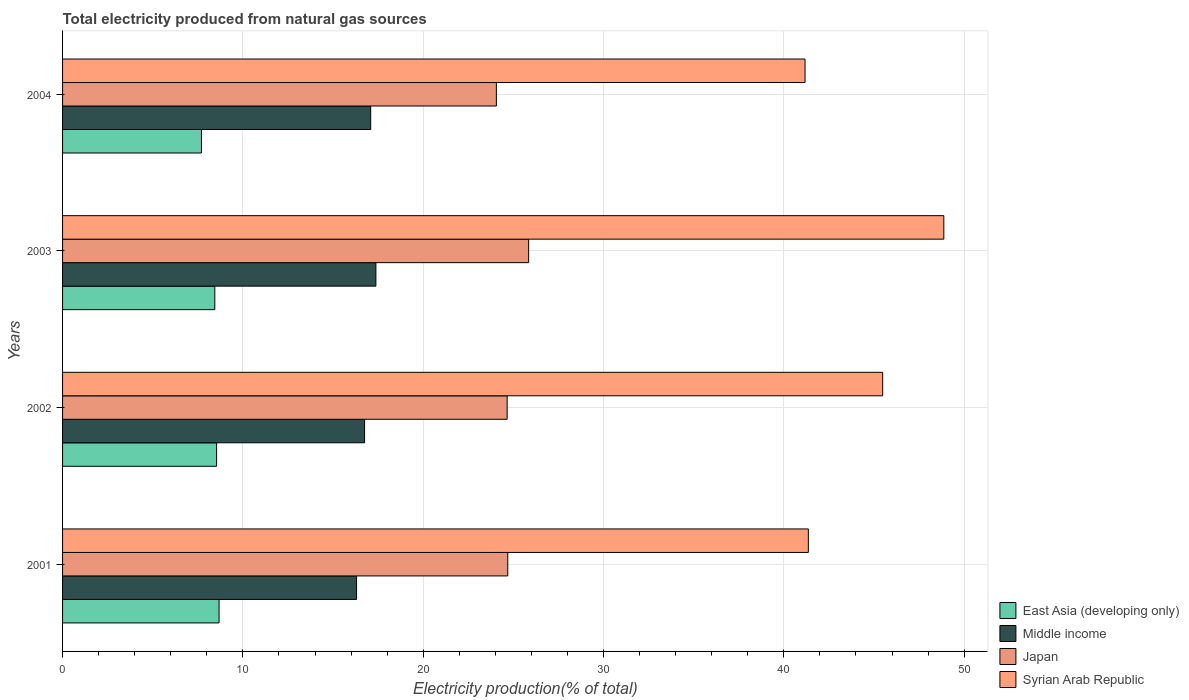How many groups of bars are there?
Your answer should be compact. 4. How many bars are there on the 3rd tick from the top?
Your response must be concise. 4. What is the label of the 1st group of bars from the top?
Keep it short and to the point. 2004. What is the total electricity produced in East Asia (developing only) in 2001?
Ensure brevity in your answer.  8.68. Across all years, what is the maximum total electricity produced in Japan?
Offer a very short reply. 25.85. Across all years, what is the minimum total electricity produced in Syrian Arab Republic?
Your answer should be compact. 41.18. In which year was the total electricity produced in East Asia (developing only) minimum?
Offer a very short reply. 2004. What is the total total electricity produced in Japan in the graph?
Offer a very short reply. 99.25. What is the difference between the total electricity produced in Middle income in 2003 and that in 2004?
Give a very brief answer. 0.29. What is the difference between the total electricity produced in Japan in 2001 and the total electricity produced in Middle income in 2003?
Keep it short and to the point. 7.31. What is the average total electricity produced in Japan per year?
Make the answer very short. 24.81. In the year 2003, what is the difference between the total electricity produced in Japan and total electricity produced in Middle income?
Provide a short and direct response. 8.47. In how many years, is the total electricity produced in Middle income greater than 8 %?
Provide a short and direct response. 4. What is the ratio of the total electricity produced in Japan in 2002 to that in 2003?
Give a very brief answer. 0.95. Is the difference between the total electricity produced in Japan in 2001 and 2003 greater than the difference between the total electricity produced in Middle income in 2001 and 2003?
Ensure brevity in your answer.  No. What is the difference between the highest and the second highest total electricity produced in Syrian Arab Republic?
Offer a terse response. 3.39. What is the difference between the highest and the lowest total electricity produced in Syrian Arab Republic?
Make the answer very short. 7.7. In how many years, is the total electricity produced in East Asia (developing only) greater than the average total electricity produced in East Asia (developing only) taken over all years?
Provide a short and direct response. 3. What does the 1st bar from the top in 2004 represents?
Offer a terse response. Syrian Arab Republic. What does the 4th bar from the bottom in 2001 represents?
Offer a very short reply. Syrian Arab Republic. What is the difference between two consecutive major ticks on the X-axis?
Keep it short and to the point. 10. Are the values on the major ticks of X-axis written in scientific E-notation?
Make the answer very short. No. Does the graph contain grids?
Provide a succinct answer. Yes. Where does the legend appear in the graph?
Make the answer very short. Bottom right. How many legend labels are there?
Provide a short and direct response. 4. What is the title of the graph?
Make the answer very short. Total electricity produced from natural gas sources. Does "Malaysia" appear as one of the legend labels in the graph?
Make the answer very short. No. What is the label or title of the X-axis?
Ensure brevity in your answer.  Electricity production(% of total). What is the Electricity production(% of total) in East Asia (developing only) in 2001?
Give a very brief answer. 8.68. What is the Electricity production(% of total) in Middle income in 2001?
Offer a very short reply. 16.31. What is the Electricity production(% of total) in Japan in 2001?
Give a very brief answer. 24.69. What is the Electricity production(% of total) in Syrian Arab Republic in 2001?
Provide a short and direct response. 41.36. What is the Electricity production(% of total) of East Asia (developing only) in 2002?
Your answer should be compact. 8.54. What is the Electricity production(% of total) in Middle income in 2002?
Make the answer very short. 16.75. What is the Electricity production(% of total) of Japan in 2002?
Ensure brevity in your answer.  24.66. What is the Electricity production(% of total) in Syrian Arab Republic in 2002?
Your answer should be compact. 45.48. What is the Electricity production(% of total) of East Asia (developing only) in 2003?
Offer a very short reply. 8.44. What is the Electricity production(% of total) of Middle income in 2003?
Make the answer very short. 17.38. What is the Electricity production(% of total) in Japan in 2003?
Your response must be concise. 25.85. What is the Electricity production(% of total) of Syrian Arab Republic in 2003?
Your answer should be very brief. 48.87. What is the Electricity production(% of total) in East Asia (developing only) in 2004?
Ensure brevity in your answer.  7.7. What is the Electricity production(% of total) in Middle income in 2004?
Your answer should be very brief. 17.09. What is the Electricity production(% of total) of Japan in 2004?
Offer a terse response. 24.06. What is the Electricity production(% of total) in Syrian Arab Republic in 2004?
Keep it short and to the point. 41.18. Across all years, what is the maximum Electricity production(% of total) of East Asia (developing only)?
Make the answer very short. 8.68. Across all years, what is the maximum Electricity production(% of total) in Middle income?
Your response must be concise. 17.38. Across all years, what is the maximum Electricity production(% of total) in Japan?
Your answer should be very brief. 25.85. Across all years, what is the maximum Electricity production(% of total) in Syrian Arab Republic?
Make the answer very short. 48.87. Across all years, what is the minimum Electricity production(% of total) in East Asia (developing only)?
Offer a very short reply. 7.7. Across all years, what is the minimum Electricity production(% of total) of Middle income?
Your answer should be very brief. 16.31. Across all years, what is the minimum Electricity production(% of total) of Japan?
Keep it short and to the point. 24.06. Across all years, what is the minimum Electricity production(% of total) of Syrian Arab Republic?
Your response must be concise. 41.18. What is the total Electricity production(% of total) in East Asia (developing only) in the graph?
Offer a very short reply. 33.37. What is the total Electricity production(% of total) in Middle income in the graph?
Your response must be concise. 67.52. What is the total Electricity production(% of total) of Japan in the graph?
Make the answer very short. 99.25. What is the total Electricity production(% of total) of Syrian Arab Republic in the graph?
Keep it short and to the point. 176.89. What is the difference between the Electricity production(% of total) in East Asia (developing only) in 2001 and that in 2002?
Ensure brevity in your answer.  0.14. What is the difference between the Electricity production(% of total) of Middle income in 2001 and that in 2002?
Offer a very short reply. -0.44. What is the difference between the Electricity production(% of total) of Japan in 2001 and that in 2002?
Your answer should be compact. 0.03. What is the difference between the Electricity production(% of total) in Syrian Arab Republic in 2001 and that in 2002?
Your answer should be compact. -4.12. What is the difference between the Electricity production(% of total) of East Asia (developing only) in 2001 and that in 2003?
Offer a very short reply. 0.24. What is the difference between the Electricity production(% of total) of Middle income in 2001 and that in 2003?
Offer a terse response. -1.07. What is the difference between the Electricity production(% of total) in Japan in 2001 and that in 2003?
Provide a succinct answer. -1.16. What is the difference between the Electricity production(% of total) of Syrian Arab Republic in 2001 and that in 2003?
Offer a terse response. -7.51. What is the difference between the Electricity production(% of total) of East Asia (developing only) in 2001 and that in 2004?
Give a very brief answer. 0.98. What is the difference between the Electricity production(% of total) in Middle income in 2001 and that in 2004?
Offer a very short reply. -0.78. What is the difference between the Electricity production(% of total) of Japan in 2001 and that in 2004?
Your response must be concise. 0.63. What is the difference between the Electricity production(% of total) in Syrian Arab Republic in 2001 and that in 2004?
Offer a very short reply. 0.18. What is the difference between the Electricity production(% of total) of East Asia (developing only) in 2002 and that in 2003?
Your response must be concise. 0.1. What is the difference between the Electricity production(% of total) of Middle income in 2002 and that in 2003?
Your answer should be compact. -0.63. What is the difference between the Electricity production(% of total) of Japan in 2002 and that in 2003?
Give a very brief answer. -1.19. What is the difference between the Electricity production(% of total) in Syrian Arab Republic in 2002 and that in 2003?
Keep it short and to the point. -3.39. What is the difference between the Electricity production(% of total) of East Asia (developing only) in 2002 and that in 2004?
Keep it short and to the point. 0.84. What is the difference between the Electricity production(% of total) of Middle income in 2002 and that in 2004?
Keep it short and to the point. -0.34. What is the difference between the Electricity production(% of total) in Japan in 2002 and that in 2004?
Give a very brief answer. 0.6. What is the difference between the Electricity production(% of total) in Syrian Arab Republic in 2002 and that in 2004?
Give a very brief answer. 4.31. What is the difference between the Electricity production(% of total) of East Asia (developing only) in 2003 and that in 2004?
Provide a succinct answer. 0.74. What is the difference between the Electricity production(% of total) of Middle income in 2003 and that in 2004?
Offer a terse response. 0.29. What is the difference between the Electricity production(% of total) in Japan in 2003 and that in 2004?
Keep it short and to the point. 1.79. What is the difference between the Electricity production(% of total) in Syrian Arab Republic in 2003 and that in 2004?
Ensure brevity in your answer.  7.7. What is the difference between the Electricity production(% of total) in East Asia (developing only) in 2001 and the Electricity production(% of total) in Middle income in 2002?
Offer a very short reply. -8.07. What is the difference between the Electricity production(% of total) of East Asia (developing only) in 2001 and the Electricity production(% of total) of Japan in 2002?
Your answer should be very brief. -15.98. What is the difference between the Electricity production(% of total) in East Asia (developing only) in 2001 and the Electricity production(% of total) in Syrian Arab Republic in 2002?
Ensure brevity in your answer.  -36.8. What is the difference between the Electricity production(% of total) of Middle income in 2001 and the Electricity production(% of total) of Japan in 2002?
Ensure brevity in your answer.  -8.35. What is the difference between the Electricity production(% of total) of Middle income in 2001 and the Electricity production(% of total) of Syrian Arab Republic in 2002?
Your response must be concise. -29.18. What is the difference between the Electricity production(% of total) in Japan in 2001 and the Electricity production(% of total) in Syrian Arab Republic in 2002?
Give a very brief answer. -20.79. What is the difference between the Electricity production(% of total) of East Asia (developing only) in 2001 and the Electricity production(% of total) of Middle income in 2003?
Provide a short and direct response. -8.7. What is the difference between the Electricity production(% of total) of East Asia (developing only) in 2001 and the Electricity production(% of total) of Japan in 2003?
Ensure brevity in your answer.  -17.17. What is the difference between the Electricity production(% of total) in East Asia (developing only) in 2001 and the Electricity production(% of total) in Syrian Arab Republic in 2003?
Give a very brief answer. -40.2. What is the difference between the Electricity production(% of total) in Middle income in 2001 and the Electricity production(% of total) in Japan in 2003?
Ensure brevity in your answer.  -9.54. What is the difference between the Electricity production(% of total) in Middle income in 2001 and the Electricity production(% of total) in Syrian Arab Republic in 2003?
Ensure brevity in your answer.  -32.57. What is the difference between the Electricity production(% of total) of Japan in 2001 and the Electricity production(% of total) of Syrian Arab Republic in 2003?
Ensure brevity in your answer.  -24.18. What is the difference between the Electricity production(% of total) of East Asia (developing only) in 2001 and the Electricity production(% of total) of Middle income in 2004?
Provide a short and direct response. -8.41. What is the difference between the Electricity production(% of total) of East Asia (developing only) in 2001 and the Electricity production(% of total) of Japan in 2004?
Provide a succinct answer. -15.38. What is the difference between the Electricity production(% of total) in East Asia (developing only) in 2001 and the Electricity production(% of total) in Syrian Arab Republic in 2004?
Make the answer very short. -32.5. What is the difference between the Electricity production(% of total) of Middle income in 2001 and the Electricity production(% of total) of Japan in 2004?
Your response must be concise. -7.75. What is the difference between the Electricity production(% of total) of Middle income in 2001 and the Electricity production(% of total) of Syrian Arab Republic in 2004?
Make the answer very short. -24.87. What is the difference between the Electricity production(% of total) of Japan in 2001 and the Electricity production(% of total) of Syrian Arab Republic in 2004?
Keep it short and to the point. -16.49. What is the difference between the Electricity production(% of total) in East Asia (developing only) in 2002 and the Electricity production(% of total) in Middle income in 2003?
Ensure brevity in your answer.  -8.84. What is the difference between the Electricity production(% of total) in East Asia (developing only) in 2002 and the Electricity production(% of total) in Japan in 2003?
Your response must be concise. -17.31. What is the difference between the Electricity production(% of total) in East Asia (developing only) in 2002 and the Electricity production(% of total) in Syrian Arab Republic in 2003?
Ensure brevity in your answer.  -40.33. What is the difference between the Electricity production(% of total) of Middle income in 2002 and the Electricity production(% of total) of Japan in 2003?
Offer a terse response. -9.1. What is the difference between the Electricity production(% of total) of Middle income in 2002 and the Electricity production(% of total) of Syrian Arab Republic in 2003?
Keep it short and to the point. -32.12. What is the difference between the Electricity production(% of total) of Japan in 2002 and the Electricity production(% of total) of Syrian Arab Republic in 2003?
Provide a succinct answer. -24.22. What is the difference between the Electricity production(% of total) of East Asia (developing only) in 2002 and the Electricity production(% of total) of Middle income in 2004?
Your response must be concise. -8.55. What is the difference between the Electricity production(% of total) in East Asia (developing only) in 2002 and the Electricity production(% of total) in Japan in 2004?
Your answer should be compact. -15.52. What is the difference between the Electricity production(% of total) of East Asia (developing only) in 2002 and the Electricity production(% of total) of Syrian Arab Republic in 2004?
Ensure brevity in your answer.  -32.63. What is the difference between the Electricity production(% of total) of Middle income in 2002 and the Electricity production(% of total) of Japan in 2004?
Your answer should be very brief. -7.31. What is the difference between the Electricity production(% of total) in Middle income in 2002 and the Electricity production(% of total) in Syrian Arab Republic in 2004?
Make the answer very short. -24.43. What is the difference between the Electricity production(% of total) in Japan in 2002 and the Electricity production(% of total) in Syrian Arab Republic in 2004?
Offer a terse response. -16.52. What is the difference between the Electricity production(% of total) in East Asia (developing only) in 2003 and the Electricity production(% of total) in Middle income in 2004?
Give a very brief answer. -8.64. What is the difference between the Electricity production(% of total) in East Asia (developing only) in 2003 and the Electricity production(% of total) in Japan in 2004?
Offer a very short reply. -15.62. What is the difference between the Electricity production(% of total) in East Asia (developing only) in 2003 and the Electricity production(% of total) in Syrian Arab Republic in 2004?
Your answer should be compact. -32.73. What is the difference between the Electricity production(% of total) in Middle income in 2003 and the Electricity production(% of total) in Japan in 2004?
Your answer should be compact. -6.68. What is the difference between the Electricity production(% of total) of Middle income in 2003 and the Electricity production(% of total) of Syrian Arab Republic in 2004?
Ensure brevity in your answer.  -23.8. What is the difference between the Electricity production(% of total) in Japan in 2003 and the Electricity production(% of total) in Syrian Arab Republic in 2004?
Offer a very short reply. -15.33. What is the average Electricity production(% of total) in East Asia (developing only) per year?
Provide a succinct answer. 8.34. What is the average Electricity production(% of total) of Middle income per year?
Offer a terse response. 16.88. What is the average Electricity production(% of total) of Japan per year?
Give a very brief answer. 24.81. What is the average Electricity production(% of total) in Syrian Arab Republic per year?
Ensure brevity in your answer.  44.22. In the year 2001, what is the difference between the Electricity production(% of total) in East Asia (developing only) and Electricity production(% of total) in Middle income?
Your answer should be compact. -7.63. In the year 2001, what is the difference between the Electricity production(% of total) in East Asia (developing only) and Electricity production(% of total) in Japan?
Keep it short and to the point. -16.01. In the year 2001, what is the difference between the Electricity production(% of total) of East Asia (developing only) and Electricity production(% of total) of Syrian Arab Republic?
Make the answer very short. -32.68. In the year 2001, what is the difference between the Electricity production(% of total) of Middle income and Electricity production(% of total) of Japan?
Your answer should be very brief. -8.38. In the year 2001, what is the difference between the Electricity production(% of total) of Middle income and Electricity production(% of total) of Syrian Arab Republic?
Ensure brevity in your answer.  -25.05. In the year 2001, what is the difference between the Electricity production(% of total) in Japan and Electricity production(% of total) in Syrian Arab Republic?
Provide a succinct answer. -16.67. In the year 2002, what is the difference between the Electricity production(% of total) of East Asia (developing only) and Electricity production(% of total) of Middle income?
Your response must be concise. -8.21. In the year 2002, what is the difference between the Electricity production(% of total) in East Asia (developing only) and Electricity production(% of total) in Japan?
Provide a short and direct response. -16.11. In the year 2002, what is the difference between the Electricity production(% of total) in East Asia (developing only) and Electricity production(% of total) in Syrian Arab Republic?
Offer a very short reply. -36.94. In the year 2002, what is the difference between the Electricity production(% of total) of Middle income and Electricity production(% of total) of Japan?
Give a very brief answer. -7.91. In the year 2002, what is the difference between the Electricity production(% of total) in Middle income and Electricity production(% of total) in Syrian Arab Republic?
Ensure brevity in your answer.  -28.73. In the year 2002, what is the difference between the Electricity production(% of total) in Japan and Electricity production(% of total) in Syrian Arab Republic?
Your answer should be very brief. -20.83. In the year 2003, what is the difference between the Electricity production(% of total) of East Asia (developing only) and Electricity production(% of total) of Middle income?
Keep it short and to the point. -8.93. In the year 2003, what is the difference between the Electricity production(% of total) in East Asia (developing only) and Electricity production(% of total) in Japan?
Your answer should be compact. -17.4. In the year 2003, what is the difference between the Electricity production(% of total) of East Asia (developing only) and Electricity production(% of total) of Syrian Arab Republic?
Offer a terse response. -40.43. In the year 2003, what is the difference between the Electricity production(% of total) in Middle income and Electricity production(% of total) in Japan?
Keep it short and to the point. -8.47. In the year 2003, what is the difference between the Electricity production(% of total) in Middle income and Electricity production(% of total) in Syrian Arab Republic?
Provide a short and direct response. -31.5. In the year 2003, what is the difference between the Electricity production(% of total) in Japan and Electricity production(% of total) in Syrian Arab Republic?
Provide a short and direct response. -23.03. In the year 2004, what is the difference between the Electricity production(% of total) of East Asia (developing only) and Electricity production(% of total) of Middle income?
Offer a terse response. -9.39. In the year 2004, what is the difference between the Electricity production(% of total) in East Asia (developing only) and Electricity production(% of total) in Japan?
Provide a succinct answer. -16.36. In the year 2004, what is the difference between the Electricity production(% of total) in East Asia (developing only) and Electricity production(% of total) in Syrian Arab Republic?
Offer a very short reply. -33.47. In the year 2004, what is the difference between the Electricity production(% of total) in Middle income and Electricity production(% of total) in Japan?
Provide a succinct answer. -6.97. In the year 2004, what is the difference between the Electricity production(% of total) in Middle income and Electricity production(% of total) in Syrian Arab Republic?
Offer a terse response. -24.09. In the year 2004, what is the difference between the Electricity production(% of total) in Japan and Electricity production(% of total) in Syrian Arab Republic?
Ensure brevity in your answer.  -17.12. What is the ratio of the Electricity production(% of total) in Middle income in 2001 to that in 2002?
Keep it short and to the point. 0.97. What is the ratio of the Electricity production(% of total) of Syrian Arab Republic in 2001 to that in 2002?
Offer a terse response. 0.91. What is the ratio of the Electricity production(% of total) of East Asia (developing only) in 2001 to that in 2003?
Ensure brevity in your answer.  1.03. What is the ratio of the Electricity production(% of total) of Middle income in 2001 to that in 2003?
Offer a very short reply. 0.94. What is the ratio of the Electricity production(% of total) in Japan in 2001 to that in 2003?
Make the answer very short. 0.96. What is the ratio of the Electricity production(% of total) of Syrian Arab Republic in 2001 to that in 2003?
Make the answer very short. 0.85. What is the ratio of the Electricity production(% of total) in East Asia (developing only) in 2001 to that in 2004?
Offer a terse response. 1.13. What is the ratio of the Electricity production(% of total) of Middle income in 2001 to that in 2004?
Your answer should be very brief. 0.95. What is the ratio of the Electricity production(% of total) of Japan in 2001 to that in 2004?
Keep it short and to the point. 1.03. What is the ratio of the Electricity production(% of total) of Syrian Arab Republic in 2001 to that in 2004?
Keep it short and to the point. 1. What is the ratio of the Electricity production(% of total) in East Asia (developing only) in 2002 to that in 2003?
Your response must be concise. 1.01. What is the ratio of the Electricity production(% of total) of Middle income in 2002 to that in 2003?
Provide a succinct answer. 0.96. What is the ratio of the Electricity production(% of total) in Japan in 2002 to that in 2003?
Keep it short and to the point. 0.95. What is the ratio of the Electricity production(% of total) of Syrian Arab Republic in 2002 to that in 2003?
Keep it short and to the point. 0.93. What is the ratio of the Electricity production(% of total) of East Asia (developing only) in 2002 to that in 2004?
Provide a short and direct response. 1.11. What is the ratio of the Electricity production(% of total) of Middle income in 2002 to that in 2004?
Ensure brevity in your answer.  0.98. What is the ratio of the Electricity production(% of total) in Japan in 2002 to that in 2004?
Ensure brevity in your answer.  1.02. What is the ratio of the Electricity production(% of total) of Syrian Arab Republic in 2002 to that in 2004?
Offer a terse response. 1.1. What is the ratio of the Electricity production(% of total) in East Asia (developing only) in 2003 to that in 2004?
Provide a short and direct response. 1.1. What is the ratio of the Electricity production(% of total) in Middle income in 2003 to that in 2004?
Offer a terse response. 1.02. What is the ratio of the Electricity production(% of total) of Japan in 2003 to that in 2004?
Give a very brief answer. 1.07. What is the ratio of the Electricity production(% of total) of Syrian Arab Republic in 2003 to that in 2004?
Provide a succinct answer. 1.19. What is the difference between the highest and the second highest Electricity production(% of total) of East Asia (developing only)?
Provide a short and direct response. 0.14. What is the difference between the highest and the second highest Electricity production(% of total) in Middle income?
Ensure brevity in your answer.  0.29. What is the difference between the highest and the second highest Electricity production(% of total) in Japan?
Make the answer very short. 1.16. What is the difference between the highest and the second highest Electricity production(% of total) of Syrian Arab Republic?
Keep it short and to the point. 3.39. What is the difference between the highest and the lowest Electricity production(% of total) of East Asia (developing only)?
Your answer should be compact. 0.98. What is the difference between the highest and the lowest Electricity production(% of total) in Middle income?
Provide a succinct answer. 1.07. What is the difference between the highest and the lowest Electricity production(% of total) in Japan?
Provide a short and direct response. 1.79. What is the difference between the highest and the lowest Electricity production(% of total) of Syrian Arab Republic?
Your response must be concise. 7.7. 